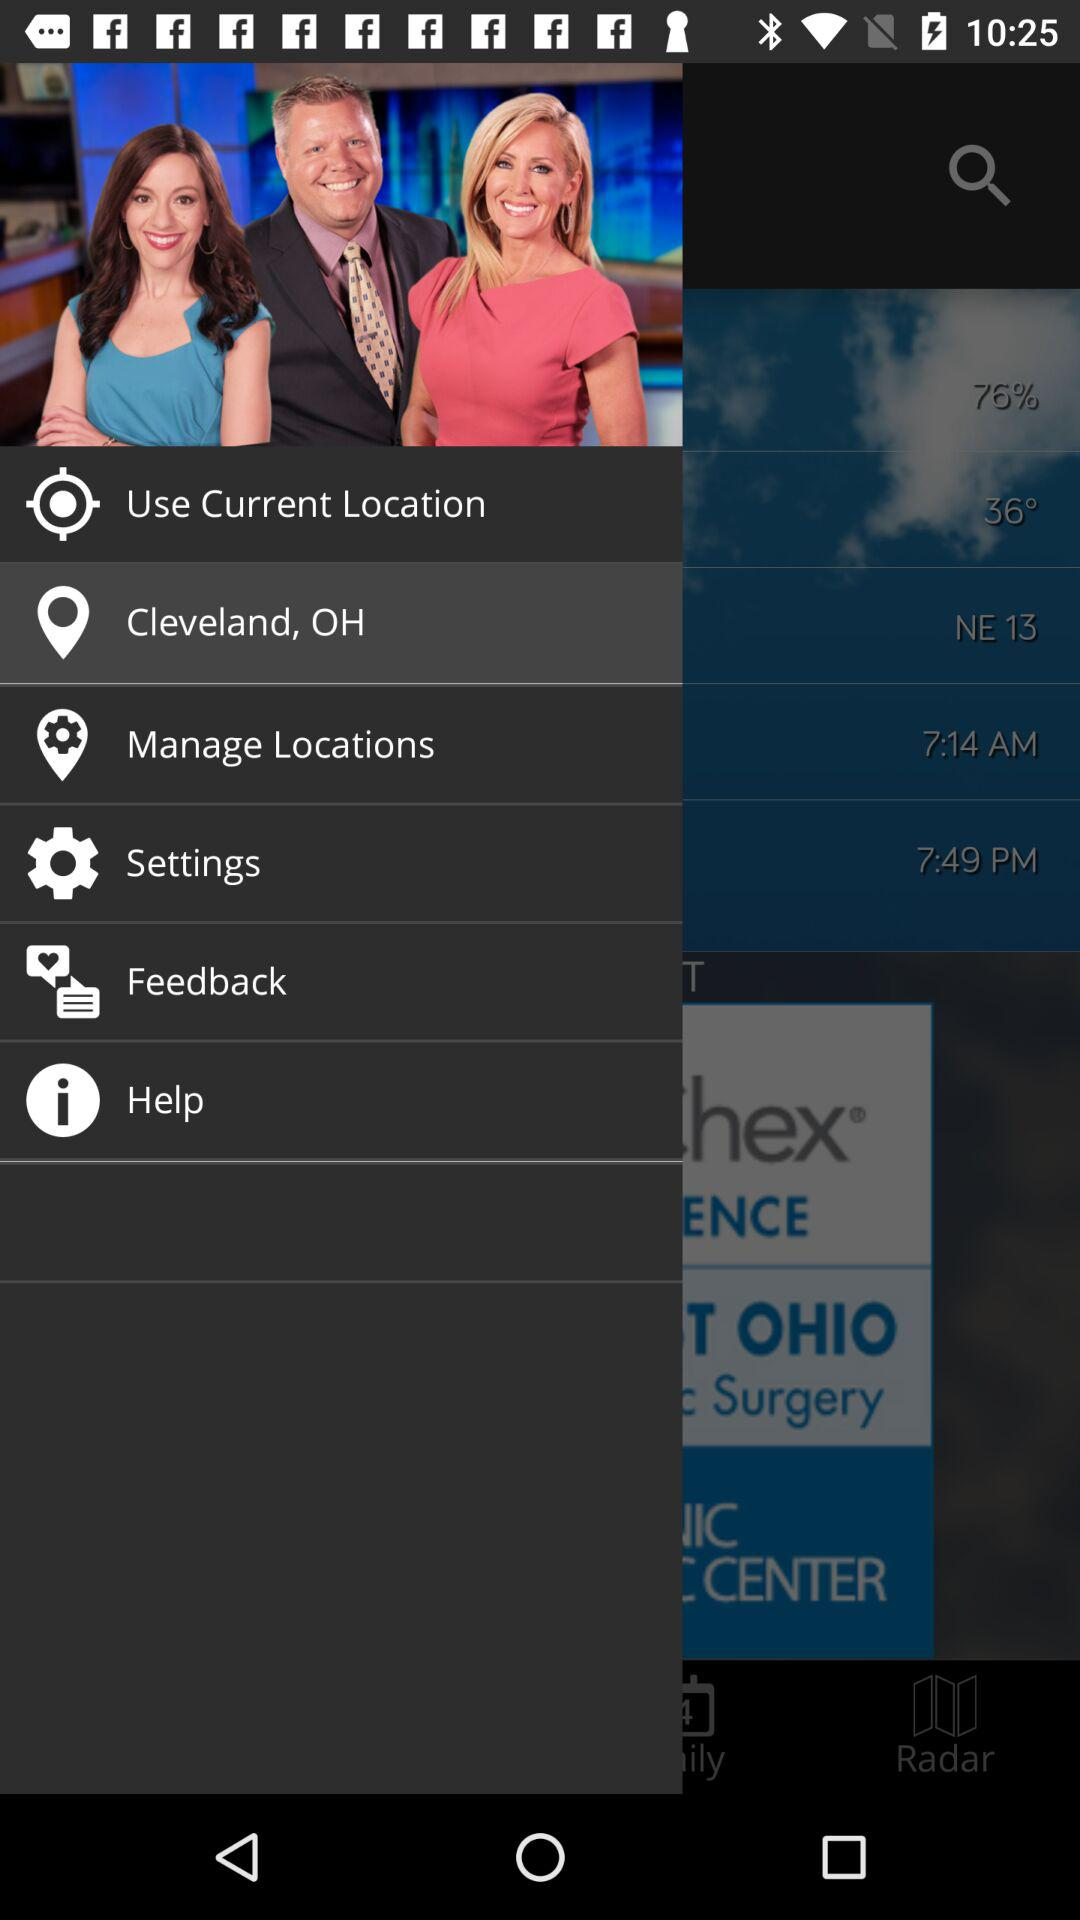How many degrees is the temperature?
Answer the question using a single word or phrase. 36° 